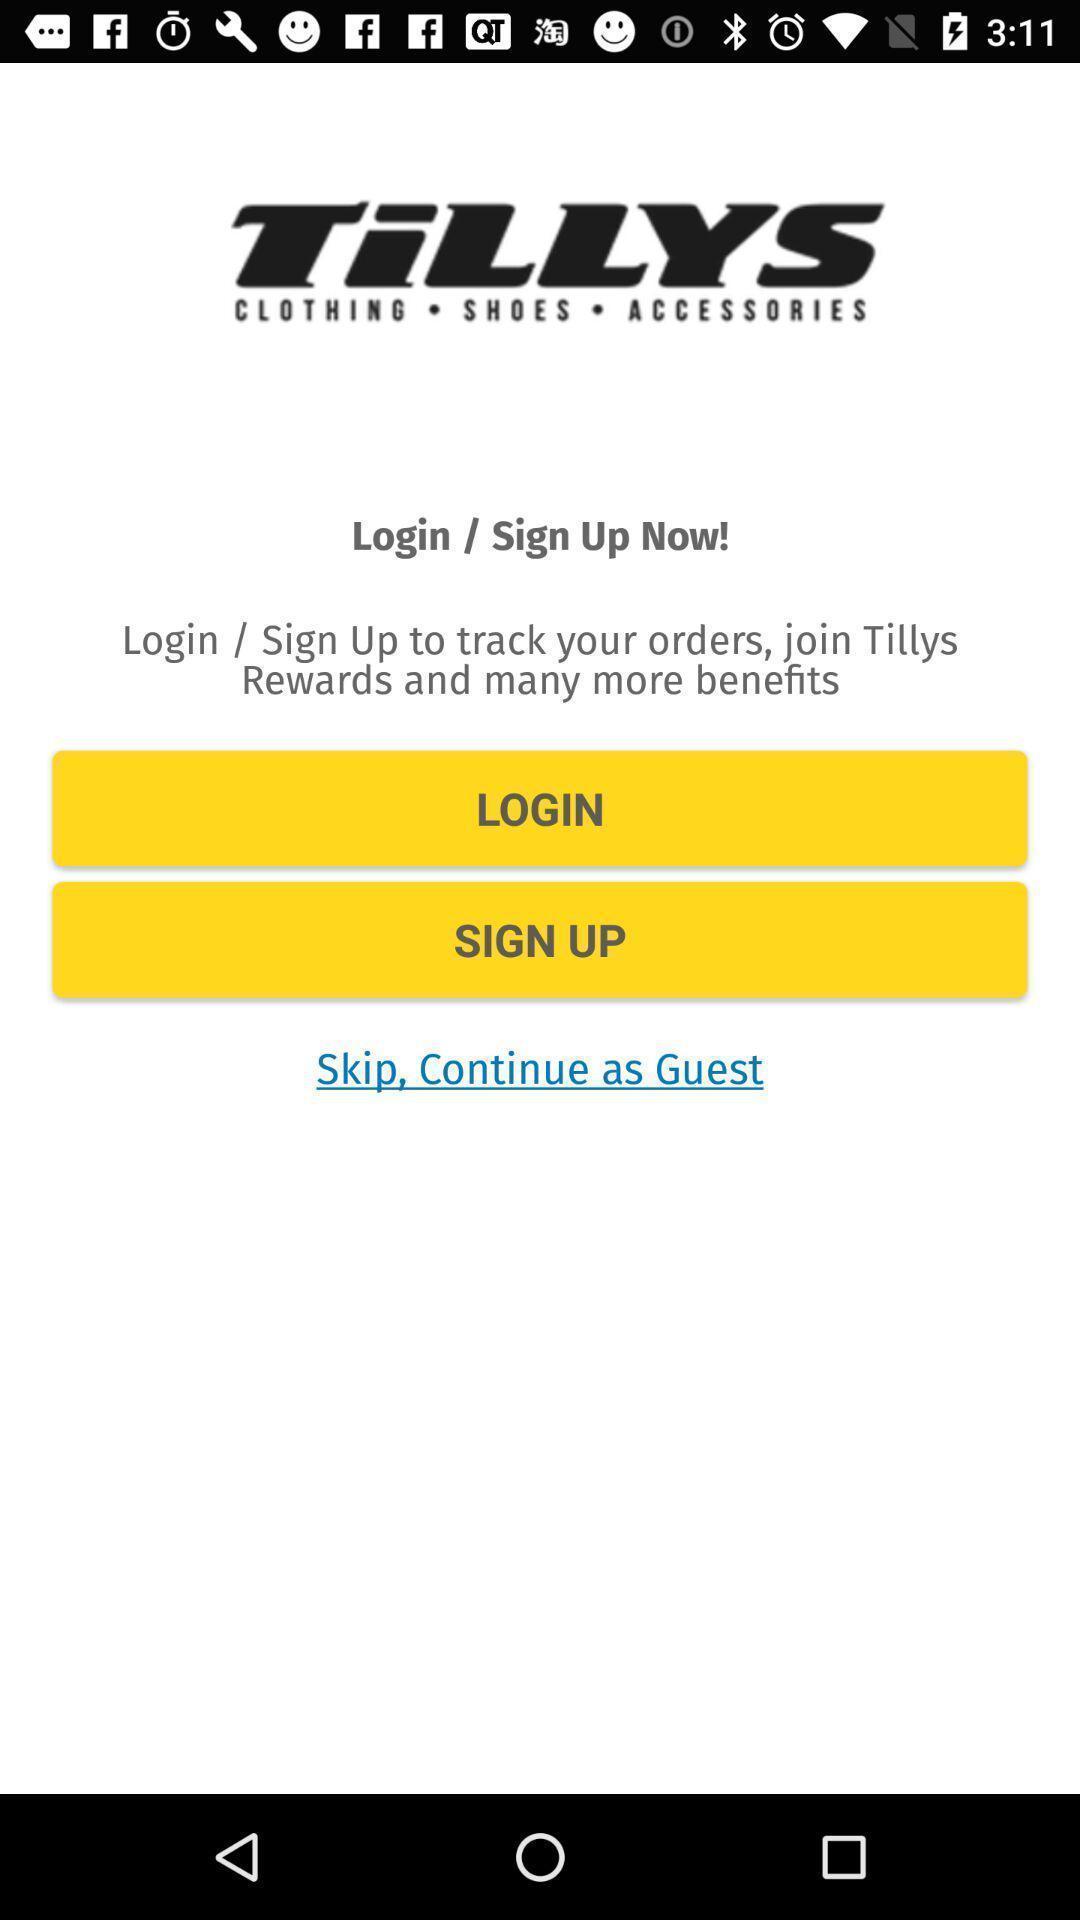Provide a description of this screenshot. Welcome page of shopping application. 